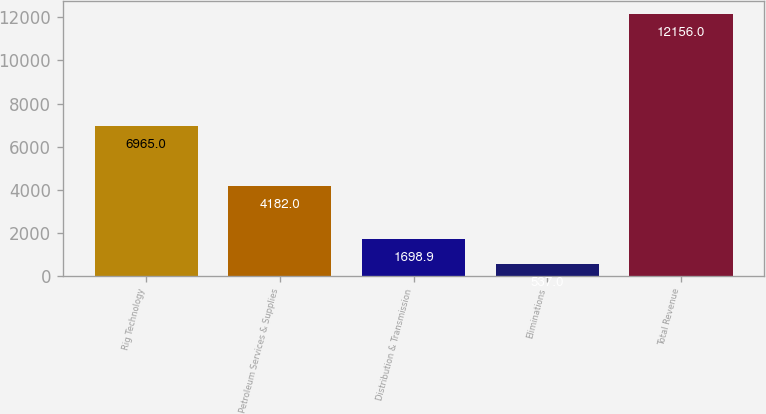Convert chart to OTSL. <chart><loc_0><loc_0><loc_500><loc_500><bar_chart><fcel>Rig Technology<fcel>Petroleum Services & Supplies<fcel>Distribution & Transmission<fcel>Eliminations<fcel>Total Revenue<nl><fcel>6965<fcel>4182<fcel>1698.9<fcel>537<fcel>12156<nl></chart> 